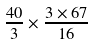Convert formula to latex. <formula><loc_0><loc_0><loc_500><loc_500>\frac { 4 0 } { 3 } \times \frac { 3 \times 6 7 } { 1 6 }</formula> 